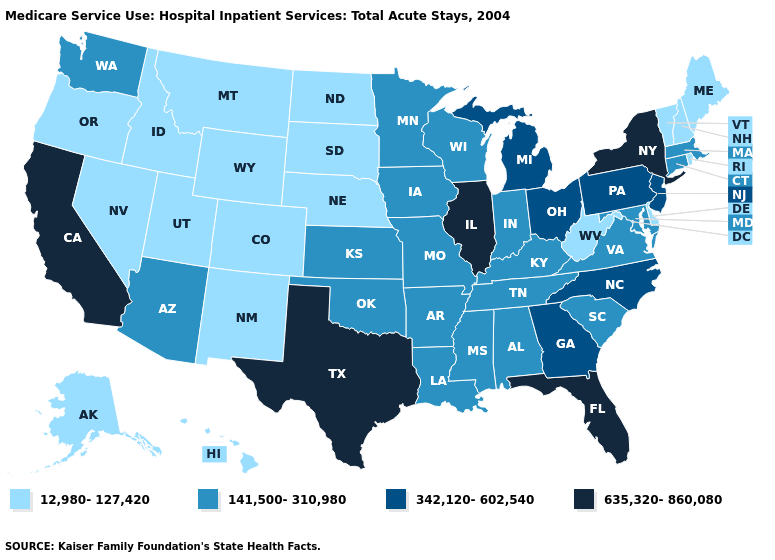Name the states that have a value in the range 141,500-310,980?
Give a very brief answer. Alabama, Arizona, Arkansas, Connecticut, Indiana, Iowa, Kansas, Kentucky, Louisiana, Maryland, Massachusetts, Minnesota, Mississippi, Missouri, Oklahoma, South Carolina, Tennessee, Virginia, Washington, Wisconsin. What is the lowest value in the USA?
Keep it brief. 12,980-127,420. Does Kentucky have the highest value in the USA?
Write a very short answer. No. Among the states that border Michigan , does Indiana have the highest value?
Concise answer only. No. Does New Jersey have the lowest value in the Northeast?
Short answer required. No. What is the lowest value in the USA?
Be succinct. 12,980-127,420. What is the value of Minnesota?
Quick response, please. 141,500-310,980. What is the value of Alaska?
Answer briefly. 12,980-127,420. Name the states that have a value in the range 12,980-127,420?
Give a very brief answer. Alaska, Colorado, Delaware, Hawaii, Idaho, Maine, Montana, Nebraska, Nevada, New Hampshire, New Mexico, North Dakota, Oregon, Rhode Island, South Dakota, Utah, Vermont, West Virginia, Wyoming. Name the states that have a value in the range 635,320-860,080?
Short answer required. California, Florida, Illinois, New York, Texas. Which states have the lowest value in the MidWest?
Give a very brief answer. Nebraska, North Dakota, South Dakota. What is the value of Hawaii?
Short answer required. 12,980-127,420. What is the value of West Virginia?
Concise answer only. 12,980-127,420. Which states hav the highest value in the Northeast?
Write a very short answer. New York. 